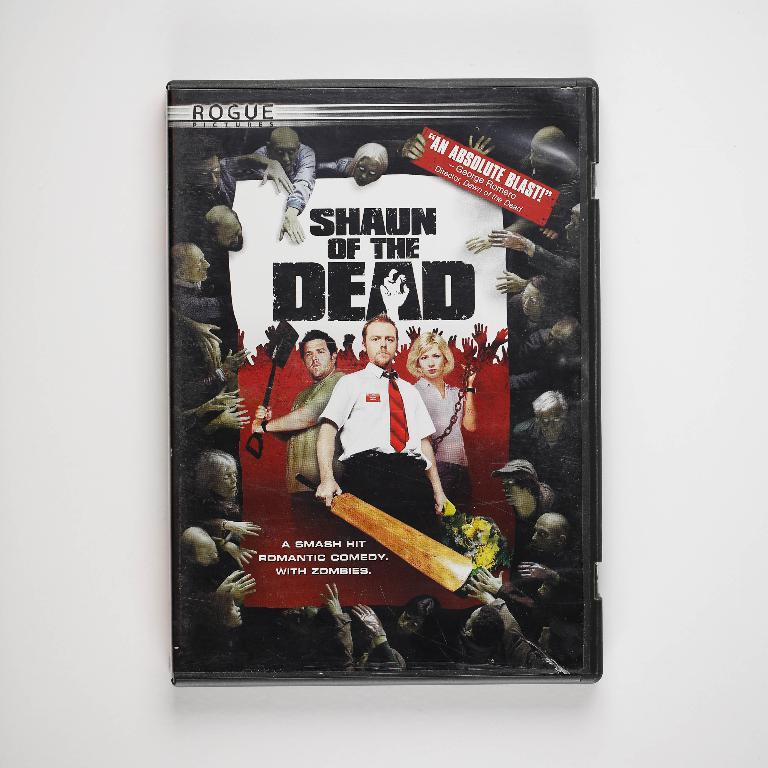<image>
Write a terse but informative summary of the picture. A movie poster for Shaun of the Dead features the main characters surrounded by zombies. 